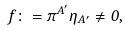Convert formula to latex. <formula><loc_0><loc_0><loc_500><loc_500>f \colon = \pi ^ { A ^ { \prime } } \eta _ { A ^ { \prime } } \neq 0 ,</formula> 